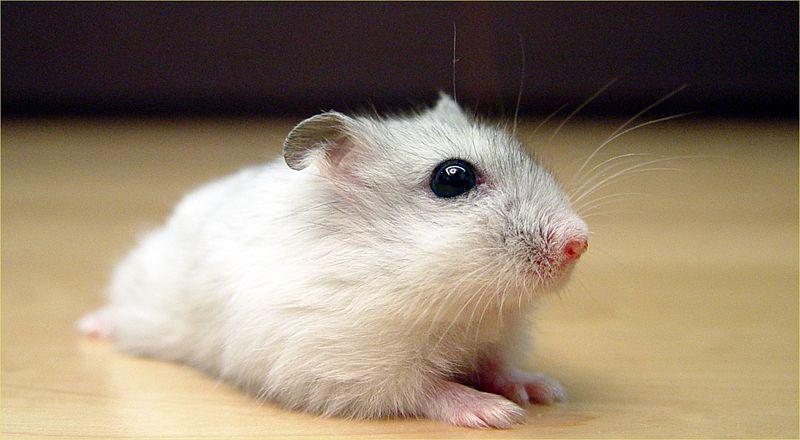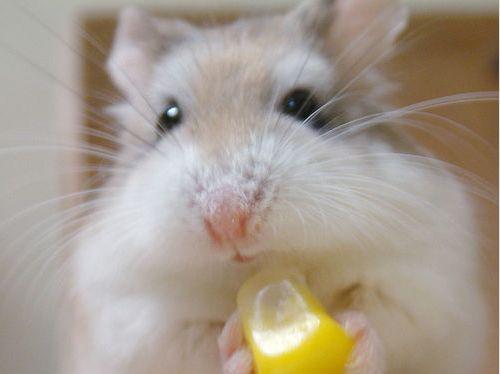The first image is the image on the left, the second image is the image on the right. Evaluate the accuracy of this statement regarding the images: "An animal is eating something yellow.". Is it true? Answer yes or no. Yes. 